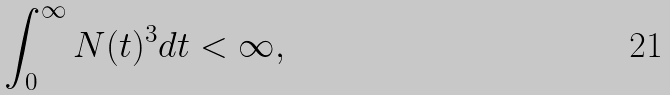Convert formula to latex. <formula><loc_0><loc_0><loc_500><loc_500>\int _ { 0 } ^ { \infty } N ( t ) ^ { 3 } d t < \infty ,</formula> 